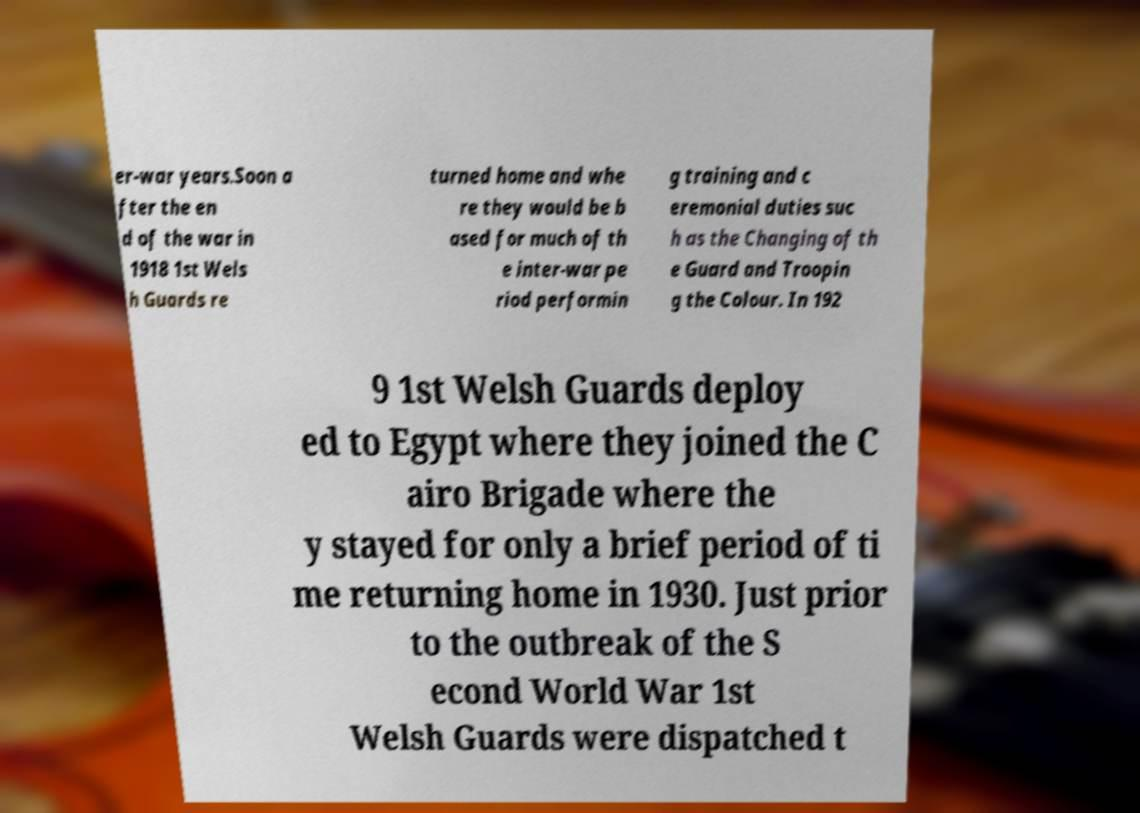For documentation purposes, I need the text within this image transcribed. Could you provide that? er-war years.Soon a fter the en d of the war in 1918 1st Wels h Guards re turned home and whe re they would be b ased for much of th e inter-war pe riod performin g training and c eremonial duties suc h as the Changing of th e Guard and Troopin g the Colour. In 192 9 1st Welsh Guards deploy ed to Egypt where they joined the C airo Brigade where the y stayed for only a brief period of ti me returning home in 1930. Just prior to the outbreak of the S econd World War 1st Welsh Guards were dispatched t 